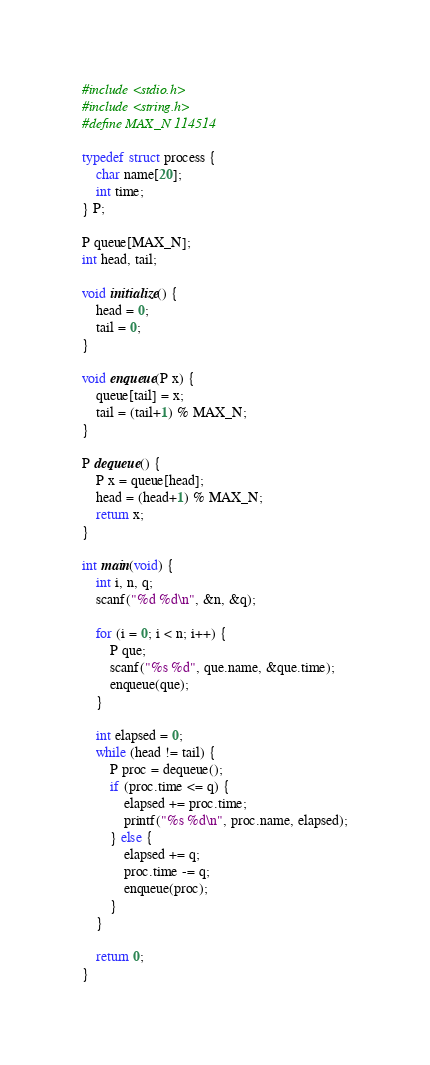Convert code to text. <code><loc_0><loc_0><loc_500><loc_500><_C_>#include <stdio.h>
#include <string.h>
#define MAX_N 114514

typedef struct process {
    char name[20];
    int time;
} P;

P queue[MAX_N];
int head, tail;

void initialize() {
    head = 0;
    tail = 0;
}

void enqueue(P x) {
    queue[tail] = x;
    tail = (tail+1) % MAX_N;
}

P dequeue() {
    P x = queue[head];
    head = (head+1) % MAX_N;
    return x;
}

int main(void) {
    int i, n, q;
    scanf("%d %d\n", &n, &q);

    for (i = 0; i < n; i++) {
        P que;
        scanf("%s %d", que.name, &que.time);
        enqueue(que);
    }

    int elapsed = 0;
    while (head != tail) {
        P proc = dequeue();
        if (proc.time <= q) {
            elapsed += proc.time;
            printf("%s %d\n", proc.name, elapsed);
        } else {
            elapsed += q;
            proc.time -= q;
            enqueue(proc);
        }
    }

    return 0;
}</code> 